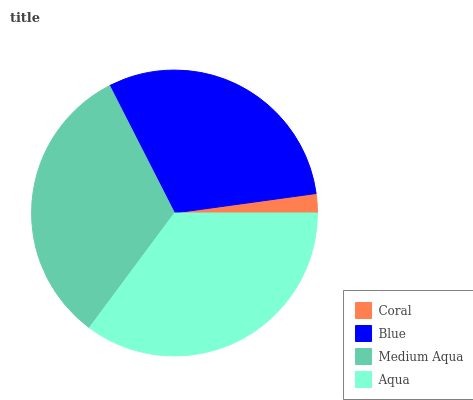Is Coral the minimum?
Answer yes or no. Yes. Is Aqua the maximum?
Answer yes or no. Yes. Is Blue the minimum?
Answer yes or no. No. Is Blue the maximum?
Answer yes or no. No. Is Blue greater than Coral?
Answer yes or no. Yes. Is Coral less than Blue?
Answer yes or no. Yes. Is Coral greater than Blue?
Answer yes or no. No. Is Blue less than Coral?
Answer yes or no. No. Is Medium Aqua the high median?
Answer yes or no. Yes. Is Blue the low median?
Answer yes or no. Yes. Is Blue the high median?
Answer yes or no. No. Is Medium Aqua the low median?
Answer yes or no. No. 